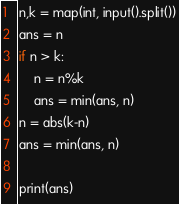<code> <loc_0><loc_0><loc_500><loc_500><_Python_>n,k = map(int, input().split())
ans = n
if n > k:
    n = n%k
    ans = min(ans, n)
n = abs(k-n)
ans = min(ans, n)

print(ans)</code> 